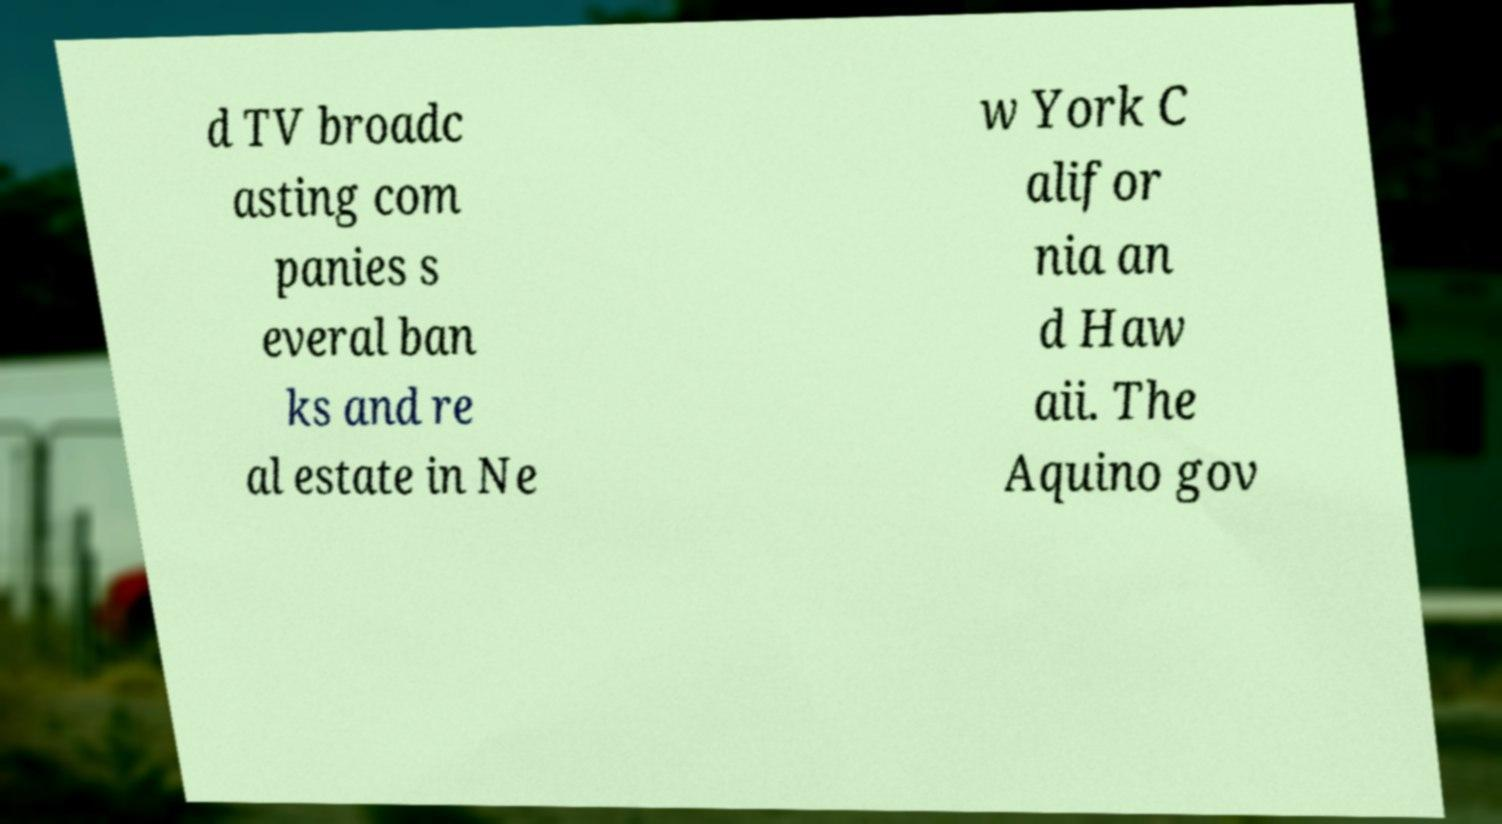What messages or text are displayed in this image? I need them in a readable, typed format. d TV broadc asting com panies s everal ban ks and re al estate in Ne w York C alifor nia an d Haw aii. The Aquino gov 